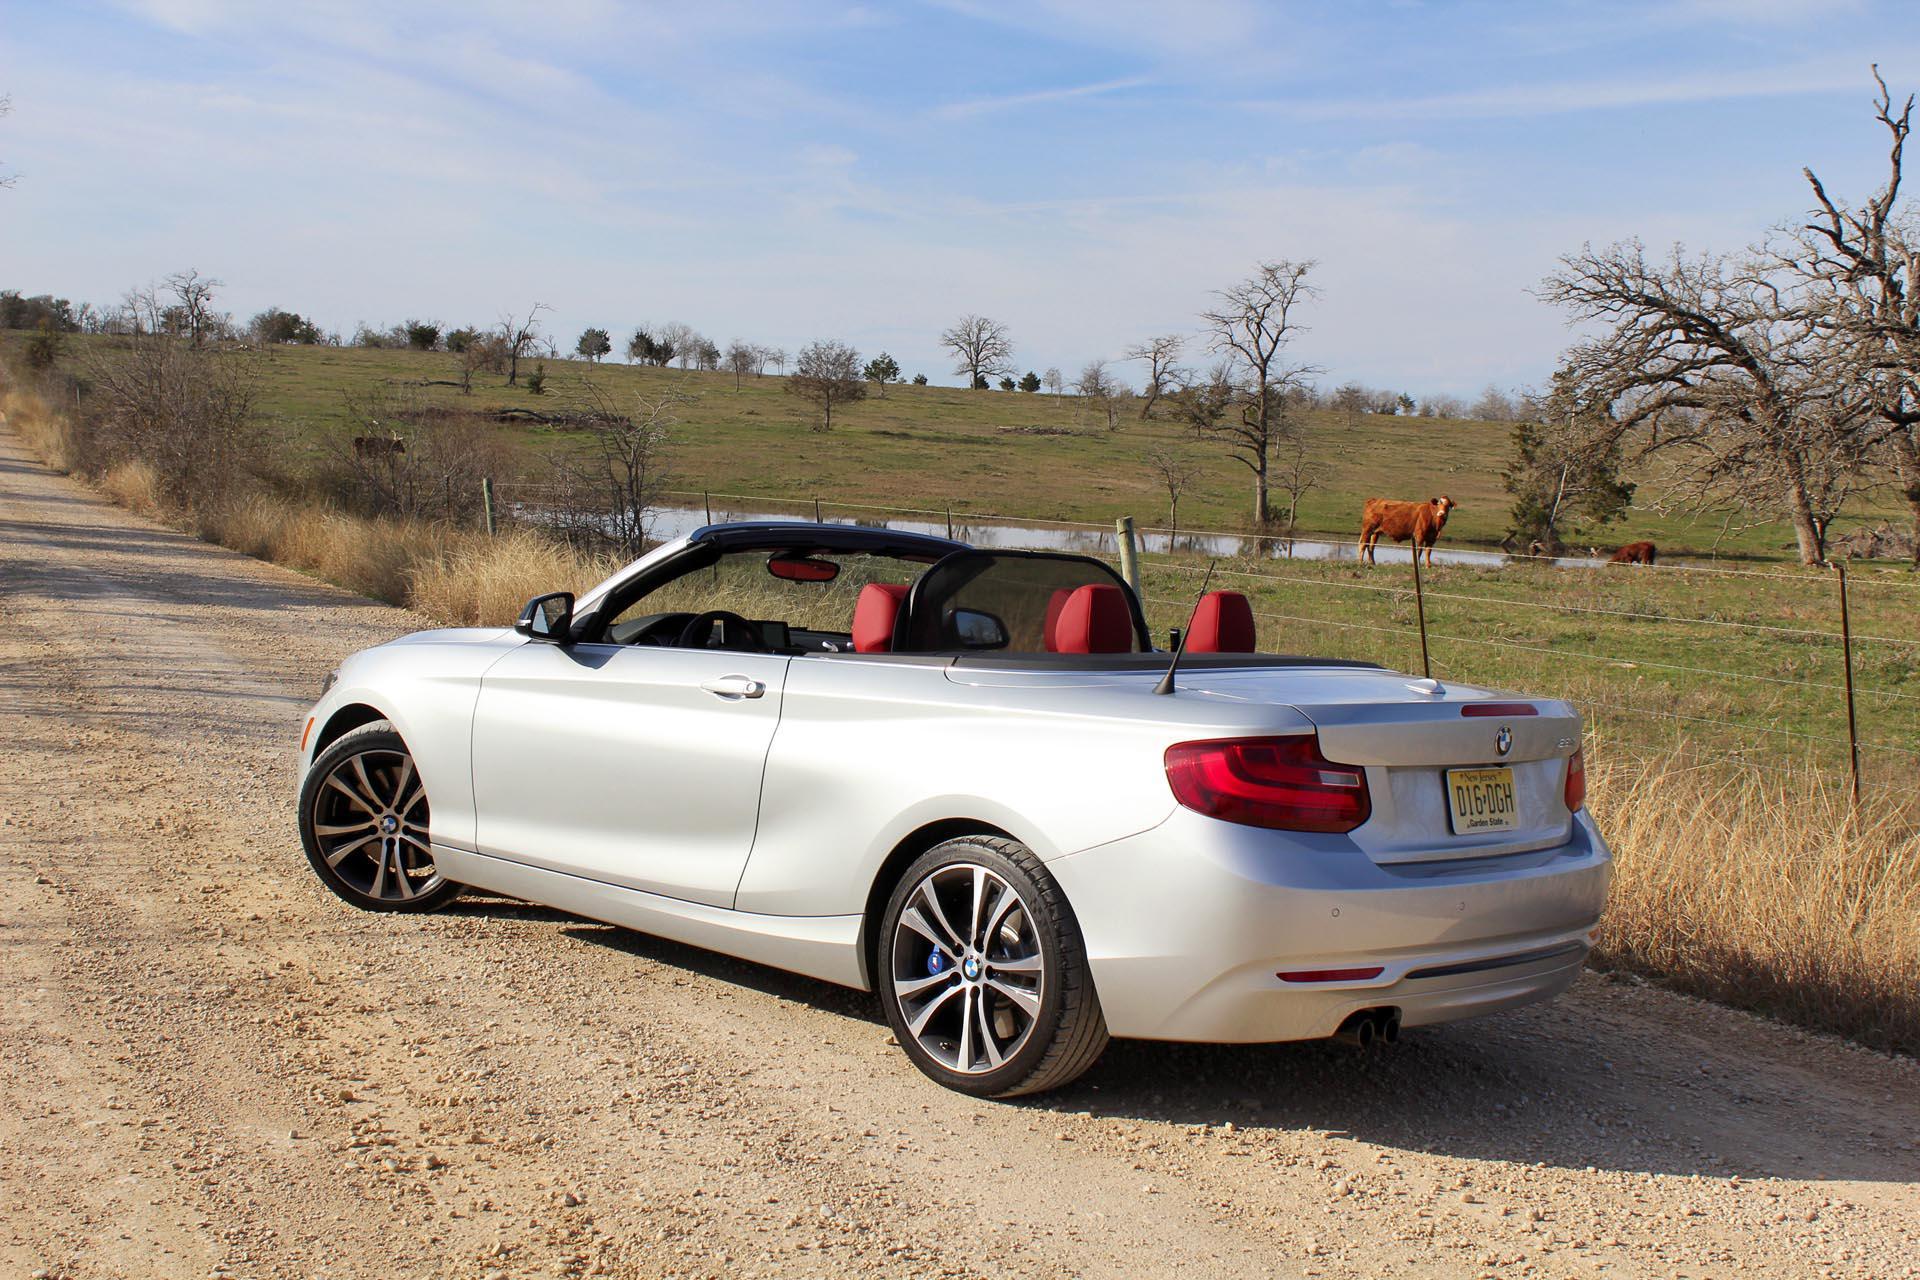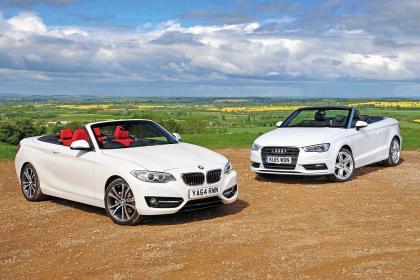The first image is the image on the left, the second image is the image on the right. Assess this claim about the two images: "An image contains exactly one parked white convertible, which has red covered seats.". Correct or not? Answer yes or no. Yes. The first image is the image on the left, the second image is the image on the right. Examine the images to the left and right. Is the description "One of the cars is black and the rest are white." accurate? Answer yes or no. No. 